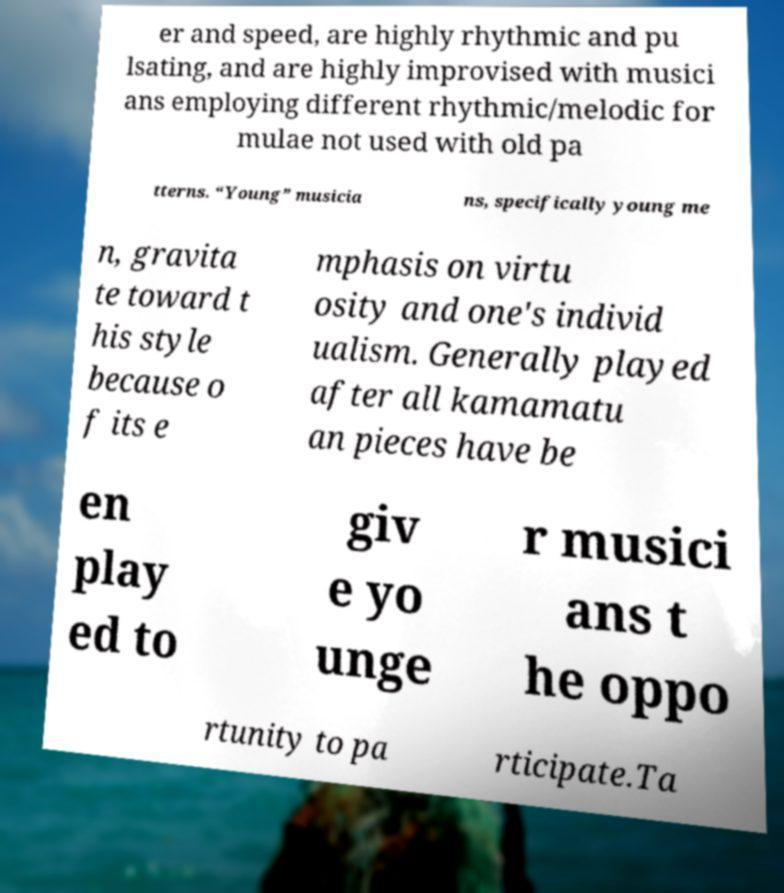For documentation purposes, I need the text within this image transcribed. Could you provide that? er and speed, are highly rhythmic and pu lsating, and are highly improvised with musici ans employing different rhythmic/melodic for mulae not used with old pa tterns. “Young” musicia ns, specifically young me n, gravita te toward t his style because o f its e mphasis on virtu osity and one's individ ualism. Generally played after all kamamatu an pieces have be en play ed to giv e yo unge r musici ans t he oppo rtunity to pa rticipate.Ta 